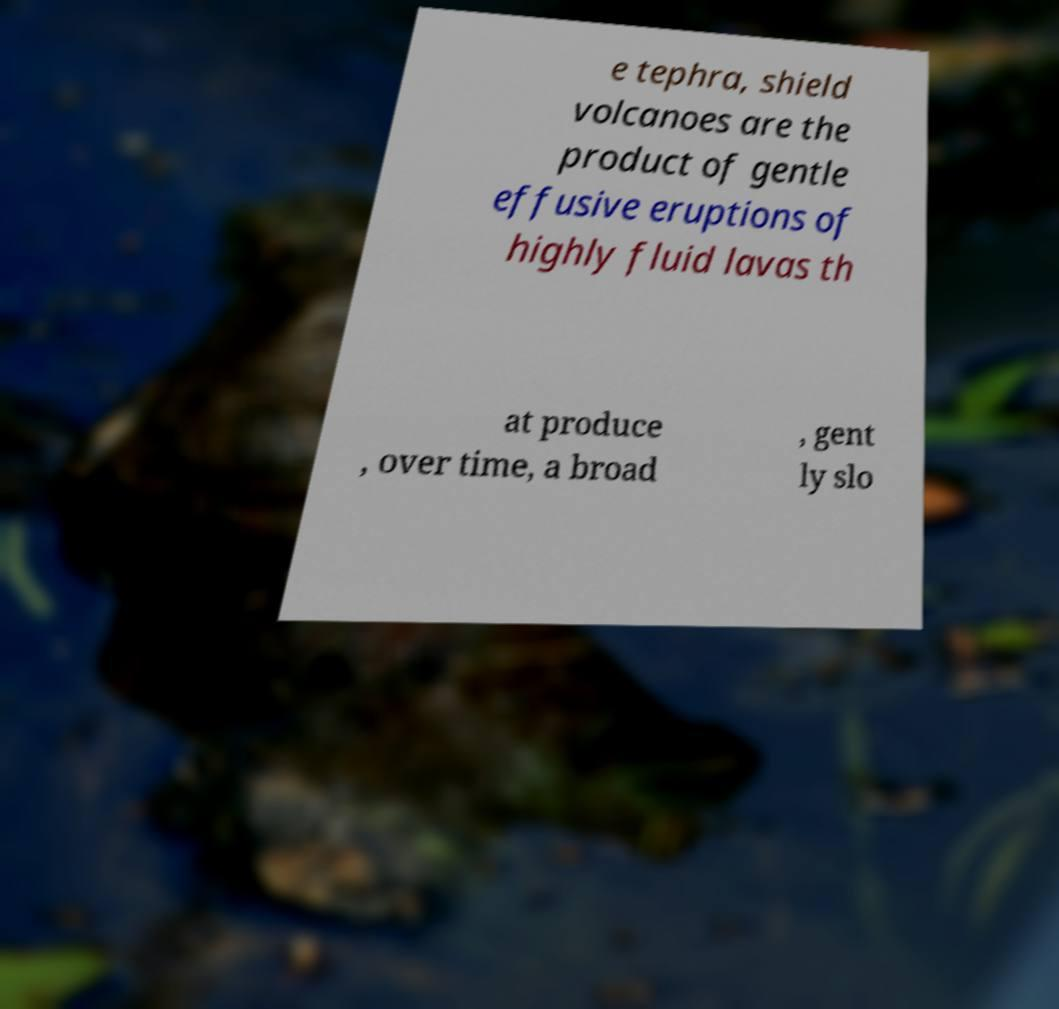Could you assist in decoding the text presented in this image and type it out clearly? e tephra, shield volcanoes are the product of gentle effusive eruptions of highly fluid lavas th at produce , over time, a broad , gent ly slo 